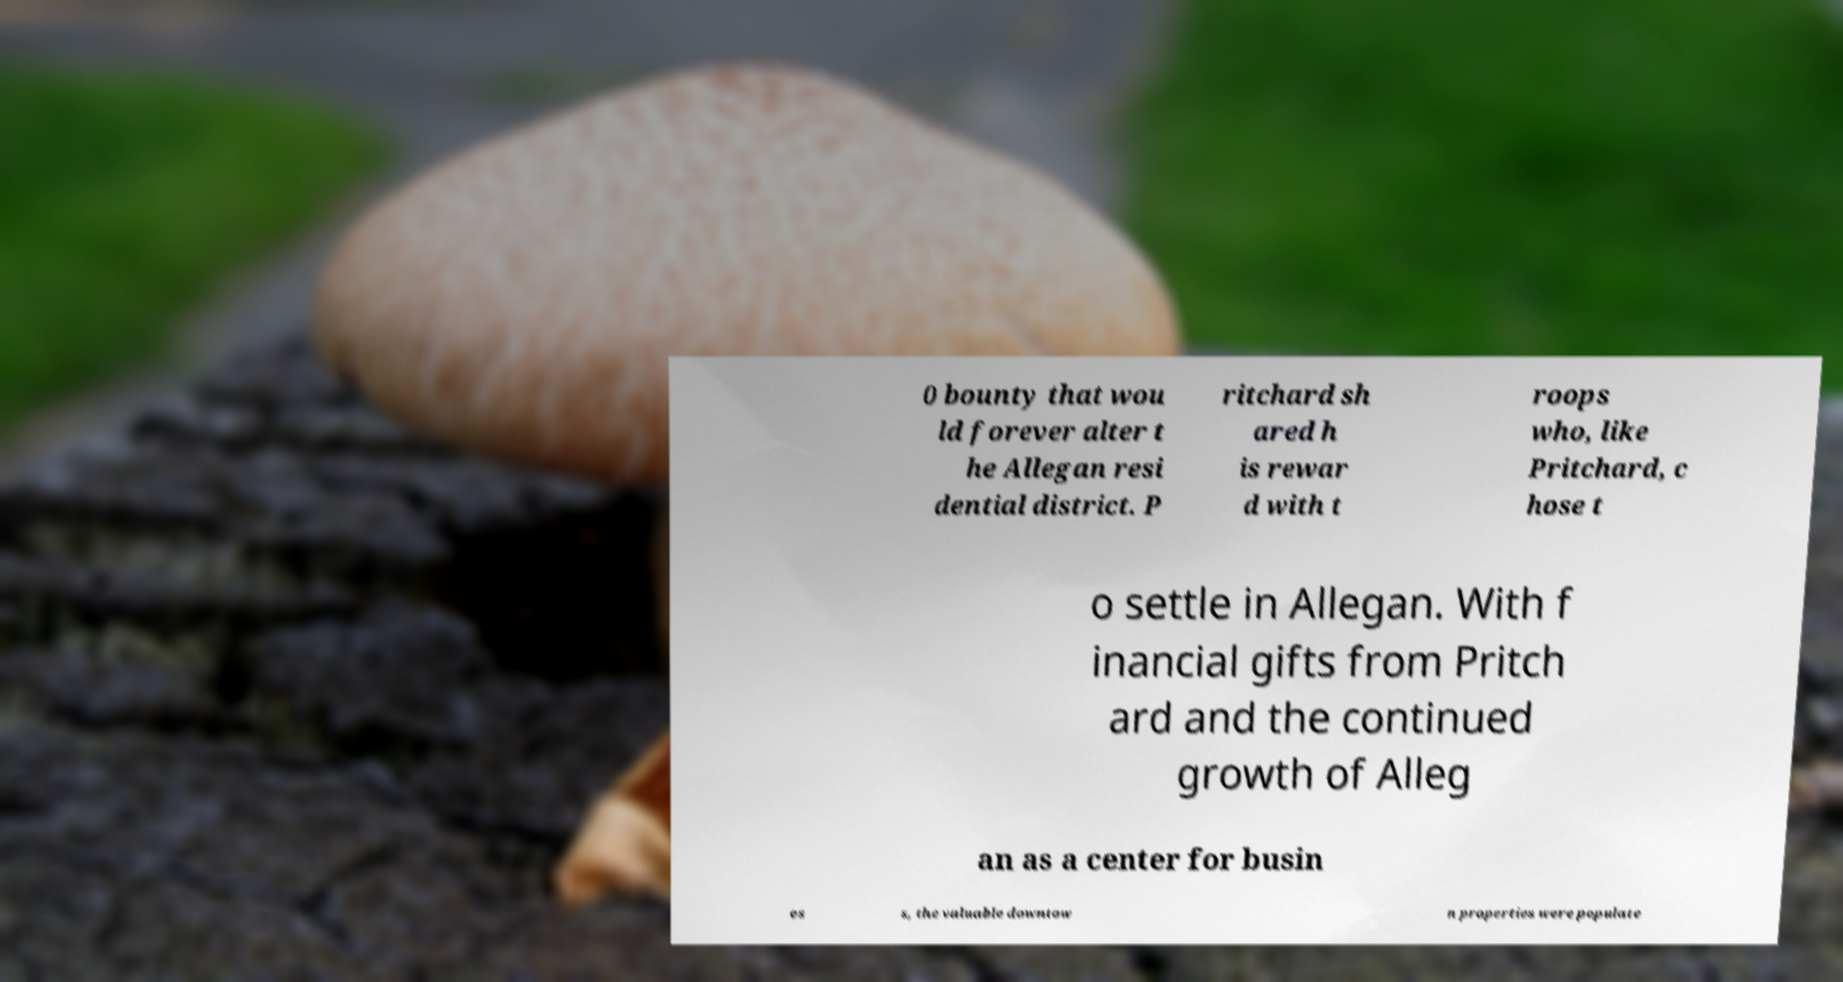There's text embedded in this image that I need extracted. Can you transcribe it verbatim? 0 bounty that wou ld forever alter t he Allegan resi dential district. P ritchard sh ared h is rewar d with t roops who, like Pritchard, c hose t o settle in Allegan. With f inancial gifts from Pritch ard and the continued growth of Alleg an as a center for busin es s, the valuable downtow n properties were populate 